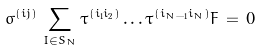<formula> <loc_0><loc_0><loc_500><loc_500>\sigma ^ { ( i j ) } \, \sum _ { I \in S _ { N } } \tau ^ { ( i _ { 1 } i _ { 2 } ) } \dots \tau ^ { ( i _ { N - 1 } i _ { N } ) } F \, = \, 0</formula> 